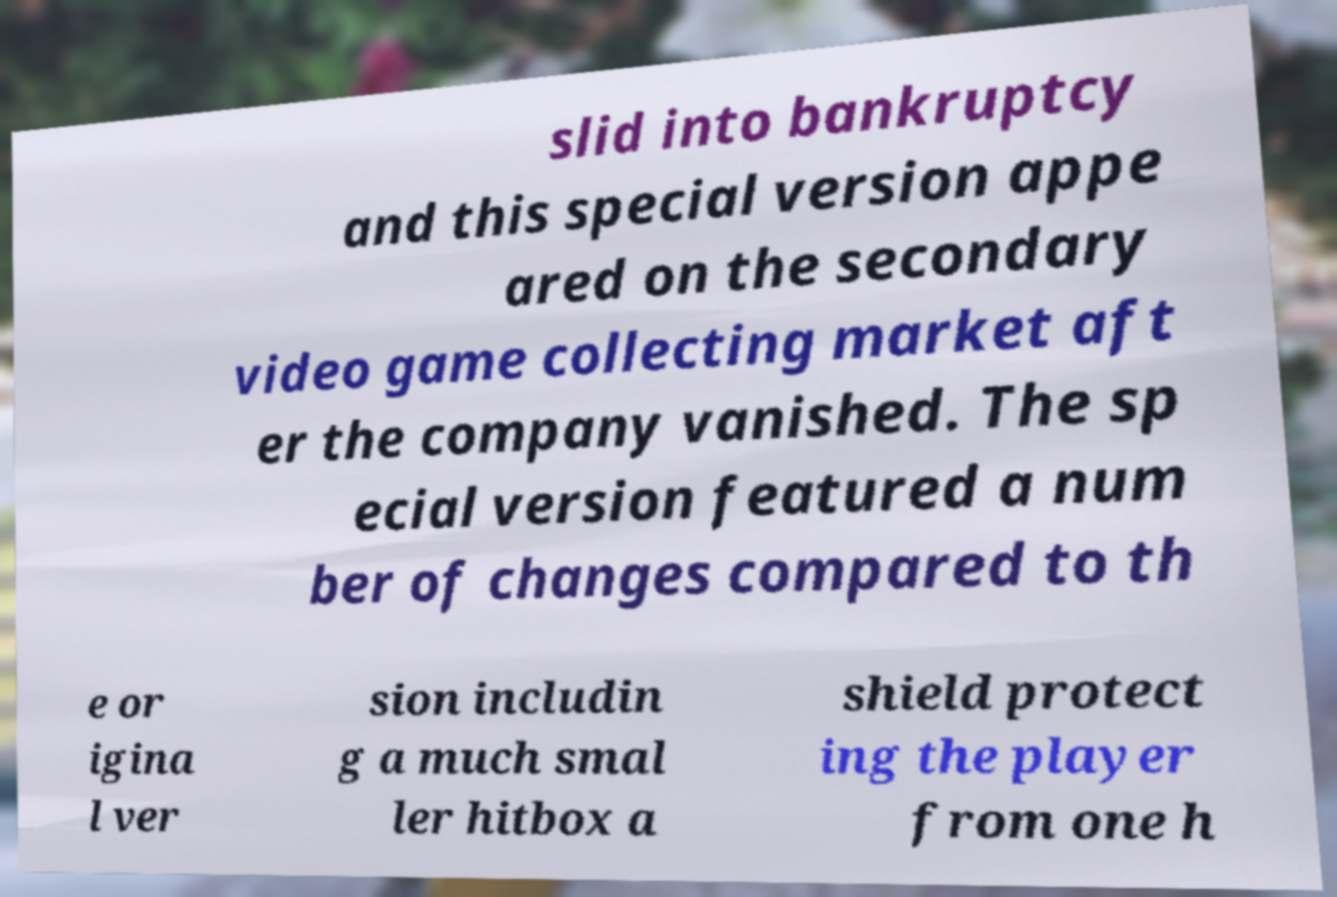Please read and relay the text visible in this image. What does it say? slid into bankruptcy and this special version appe ared on the secondary video game collecting market aft er the company vanished. The sp ecial version featured a num ber of changes compared to th e or igina l ver sion includin g a much smal ler hitbox a shield protect ing the player from one h 